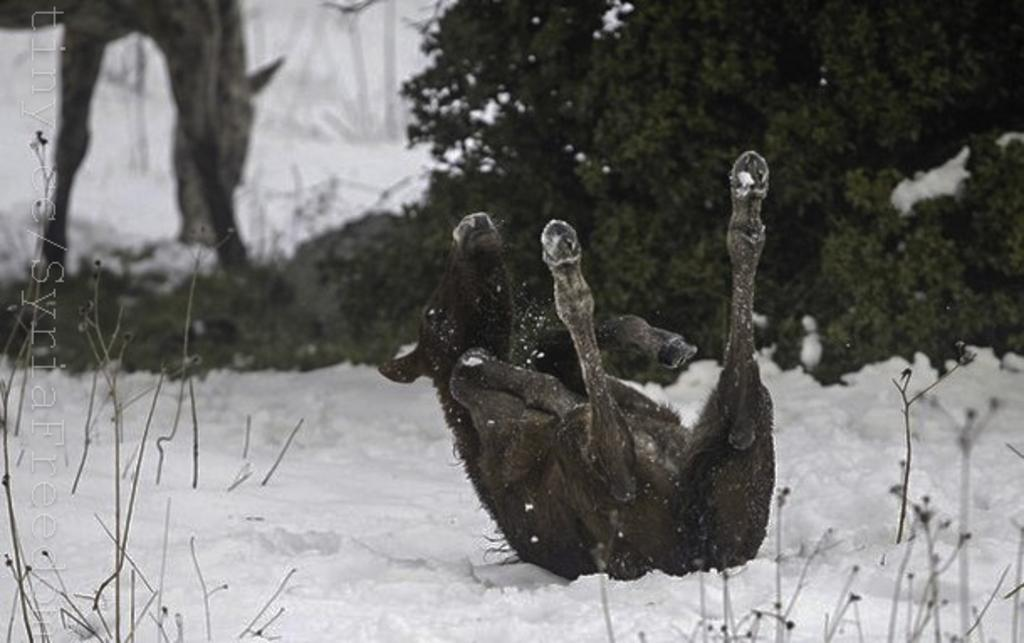What can be seen in the foreground of the picture? In the foreground of the picture, there are plants, snow, and an animal. What is present in the background of the picture? In the background of the picture, there are plants, snow, and an animal. How is the top part of the image described? The top part of the image is blurred. What can be found on the left side of the image? There is text on the left side of the image. What type of instrument is being played by the rat in the image? There is no rat or instrument present in the image. What kind of cake is being served in the background of the image? There is no cake present in the image. 